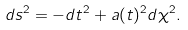<formula> <loc_0><loc_0><loc_500><loc_500>d s ^ { 2 } = - d t ^ { 2 } + a ( t ) ^ { 2 } d \chi ^ { 2 } .</formula> 